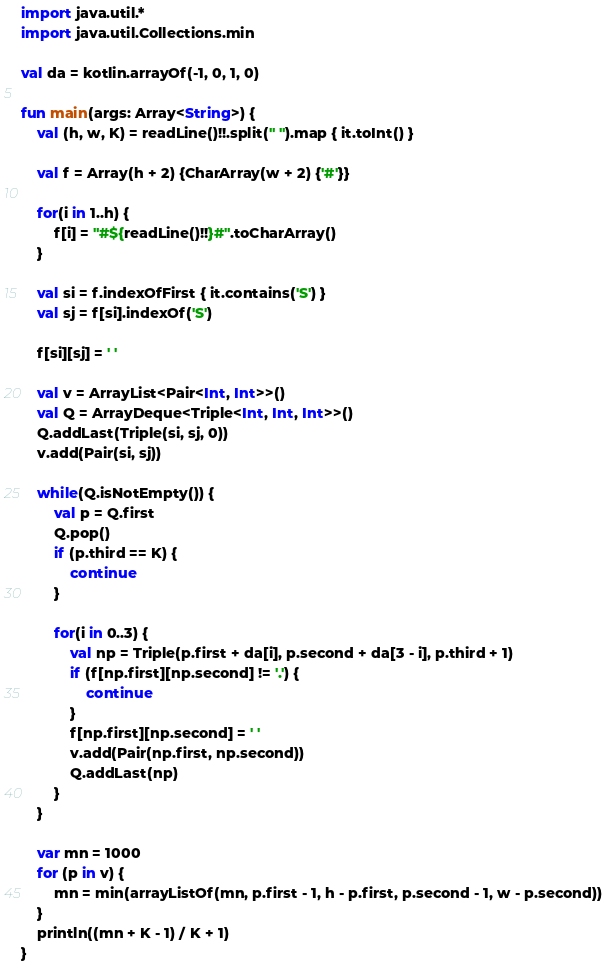<code> <loc_0><loc_0><loc_500><loc_500><_Kotlin_>import java.util.*
import java.util.Collections.min

val da = kotlin.arrayOf(-1, 0, 1, 0)

fun main(args: Array<String>) {
    val (h, w, K) = readLine()!!.split(" ").map { it.toInt() }

    val f = Array(h + 2) {CharArray(w + 2) {'#'}}

    for(i in 1..h) {
        f[i] = "#${readLine()!!}#".toCharArray()
    }

    val si = f.indexOfFirst { it.contains('S') }
    val sj = f[si].indexOf('S')

    f[si][sj] = ' '

    val v = ArrayList<Pair<Int, Int>>()
    val Q = ArrayDeque<Triple<Int, Int, Int>>()
    Q.addLast(Triple(si, sj, 0))
    v.add(Pair(si, sj))

    while(Q.isNotEmpty()) {
        val p = Q.first
        Q.pop()
        if (p.third == K) {
            continue
        }

        for(i in 0..3) {
            val np = Triple(p.first + da[i], p.second + da[3 - i], p.third + 1)
            if (f[np.first][np.second] != '.') {
                continue
            }
            f[np.first][np.second] = ' '
            v.add(Pair(np.first, np.second))
            Q.addLast(np)
        }
    }

    var mn = 1000
    for (p in v) {
        mn = min(arrayListOf(mn, p.first - 1, h - p.first, p.second - 1, w - p.second))
    }
    println((mn + K - 1) / K + 1)
}
</code> 